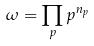Convert formula to latex. <formula><loc_0><loc_0><loc_500><loc_500>\omega = \prod _ { p } p ^ { n _ { p } }</formula> 